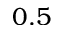Convert formula to latex. <formula><loc_0><loc_0><loc_500><loc_500>0 . 5</formula> 